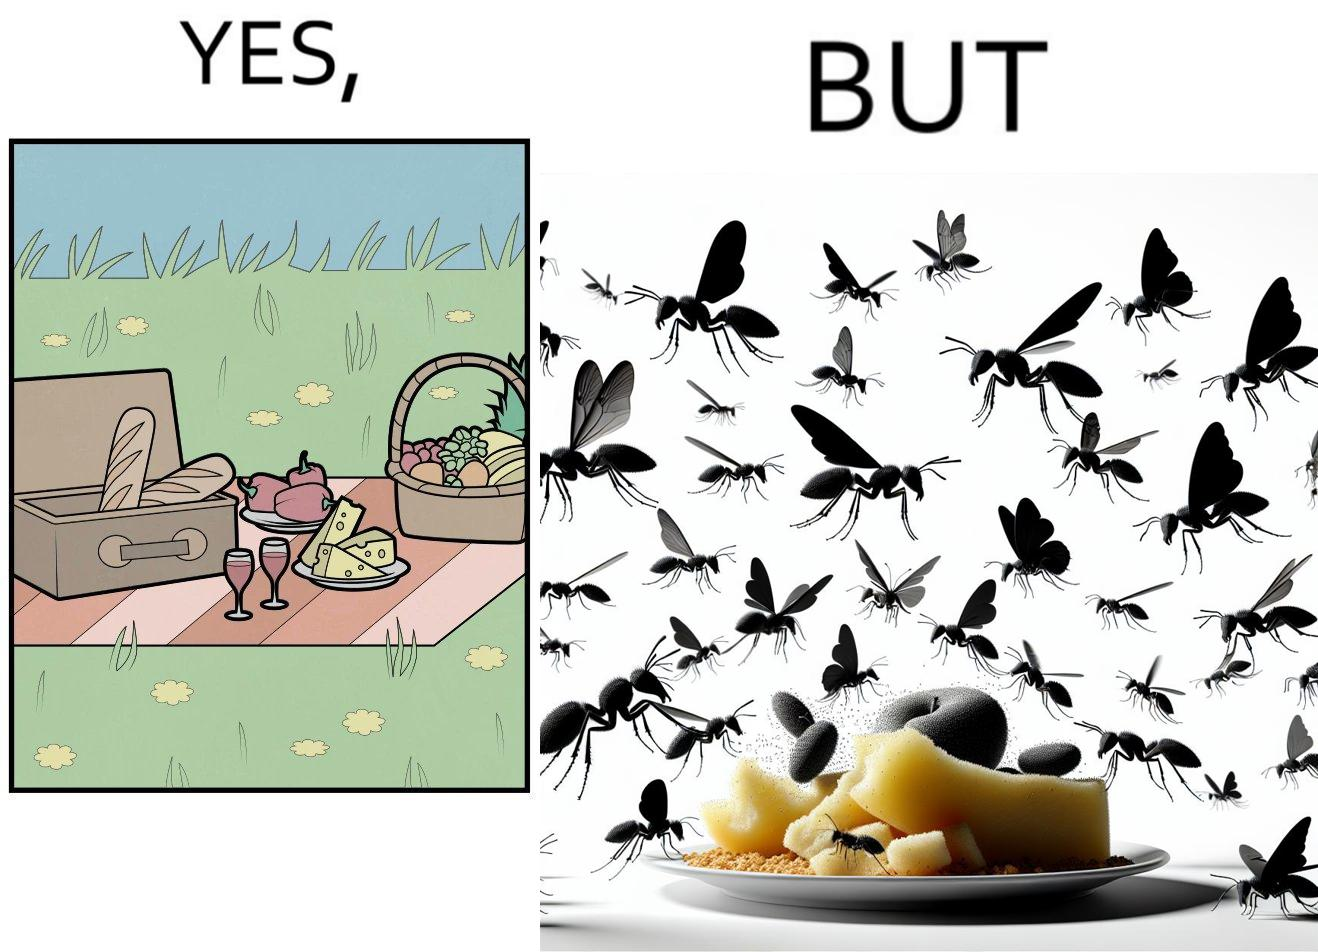Is this a satirical image? Yes, this image is satirical. 